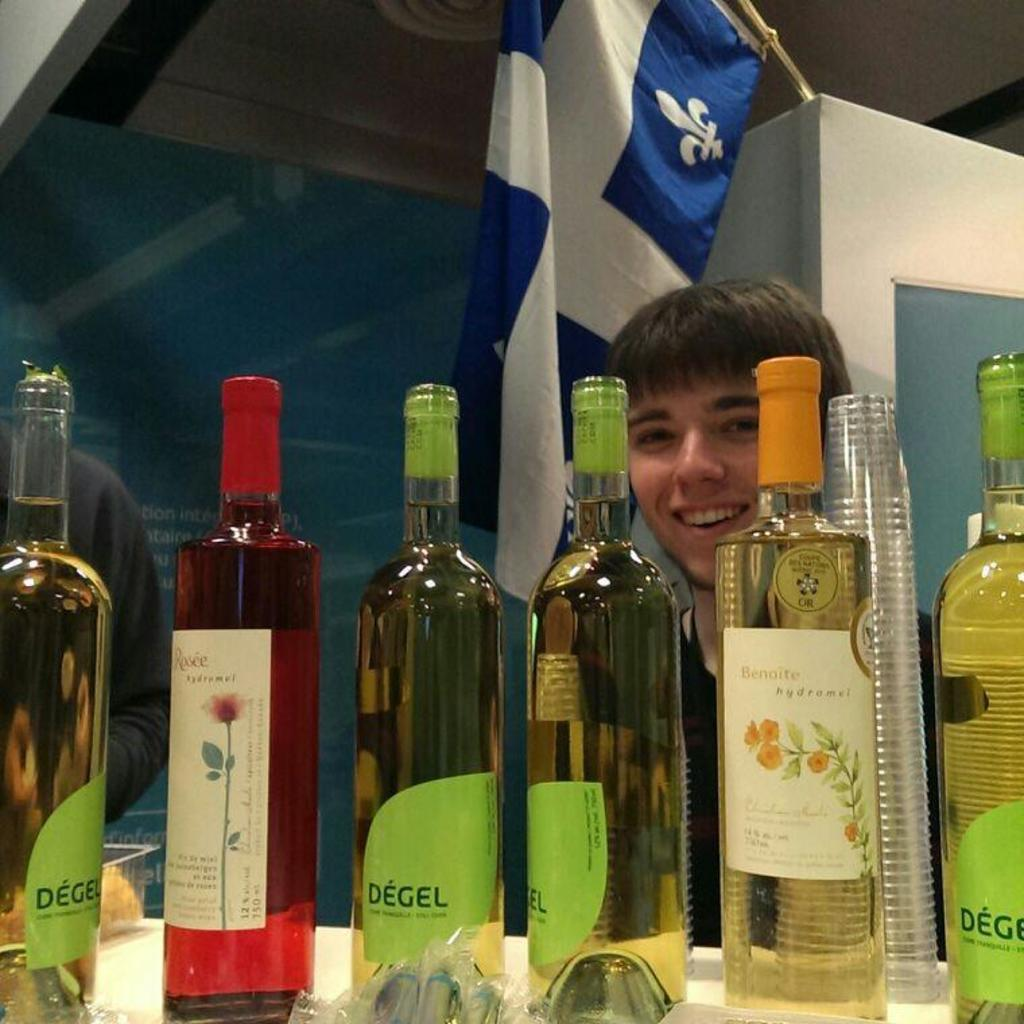<image>
Share a concise interpretation of the image provided. Several bottles of Degel alcohol on a table. 